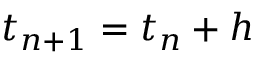<formula> <loc_0><loc_0><loc_500><loc_500>t _ { n + 1 } = t _ { n } + h</formula> 